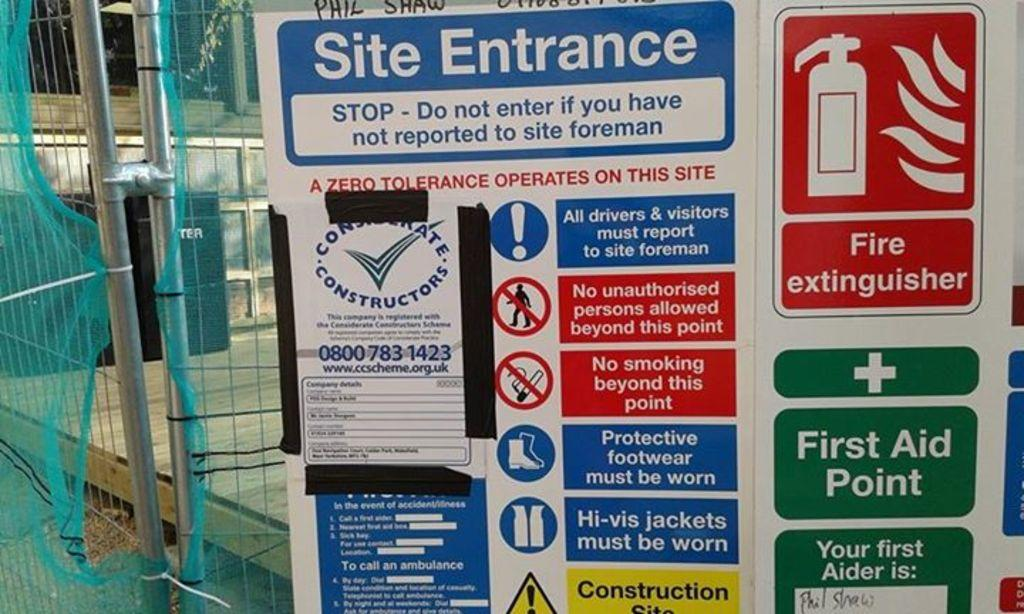<image>
Relay a brief, clear account of the picture shown. The poster gives alot of important information including the first aid point and the name of the first aider. 